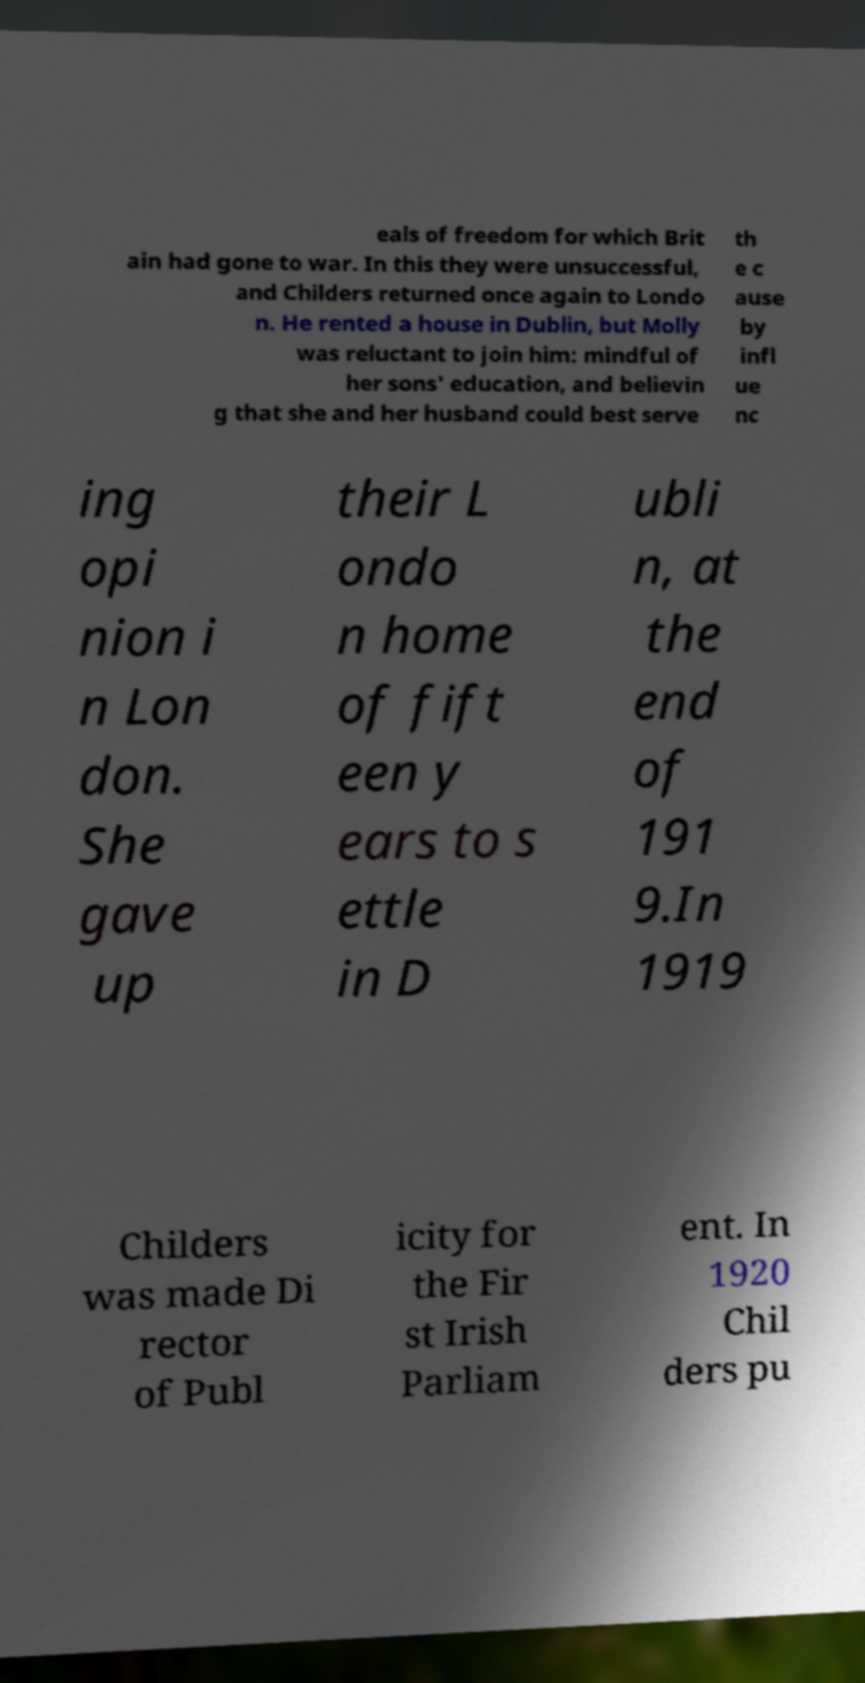Could you extract and type out the text from this image? eals of freedom for which Brit ain had gone to war. In this they were unsuccessful, and Childers returned once again to Londo n. He rented a house in Dublin, but Molly was reluctant to join him: mindful of her sons' education, and believin g that she and her husband could best serve th e c ause by infl ue nc ing opi nion i n Lon don. She gave up their L ondo n home of fift een y ears to s ettle in D ubli n, at the end of 191 9.In 1919 Childers was made Di rector of Publ icity for the Fir st Irish Parliam ent. In 1920 Chil ders pu 